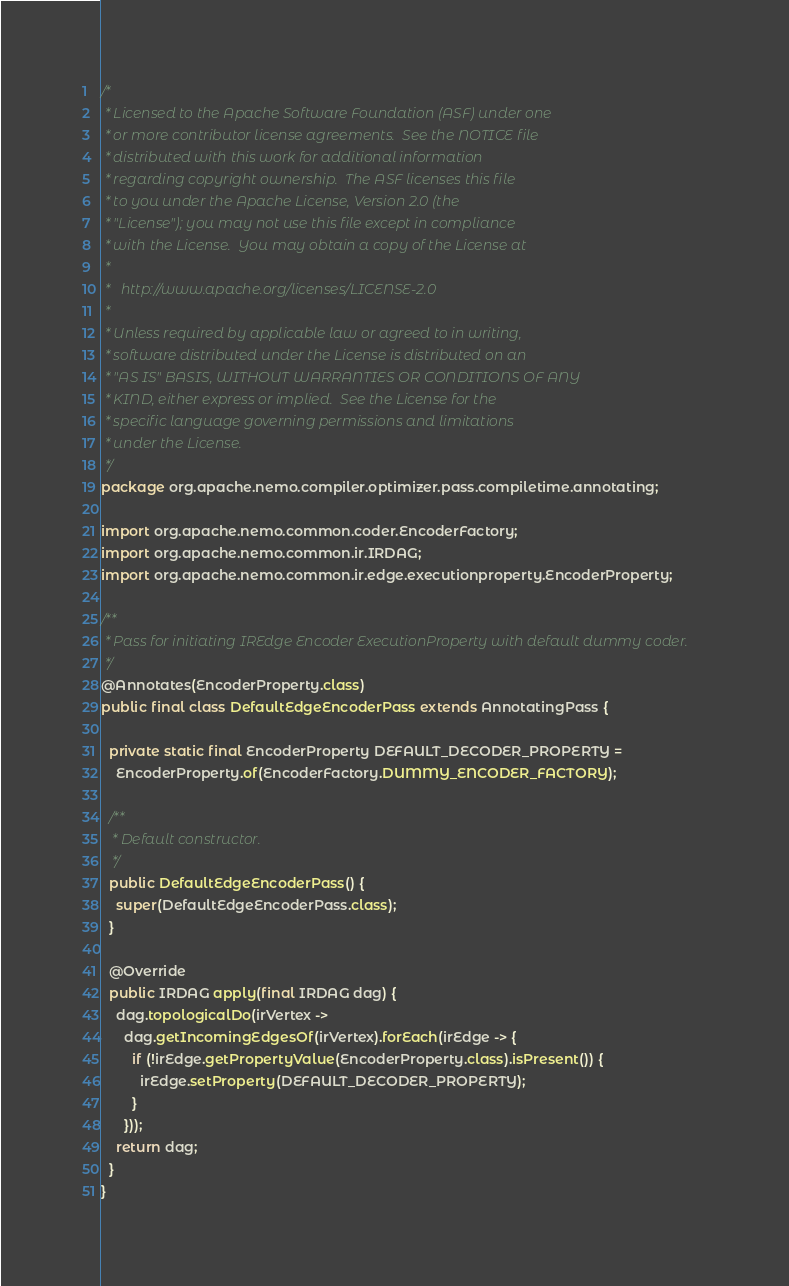<code> <loc_0><loc_0><loc_500><loc_500><_Java_>/*
 * Licensed to the Apache Software Foundation (ASF) under one
 * or more contributor license agreements.  See the NOTICE file
 * distributed with this work for additional information
 * regarding copyright ownership.  The ASF licenses this file
 * to you under the Apache License, Version 2.0 (the
 * "License"); you may not use this file except in compliance
 * with the License.  You may obtain a copy of the License at
 *
 *   http://www.apache.org/licenses/LICENSE-2.0
 *
 * Unless required by applicable law or agreed to in writing,
 * software distributed under the License is distributed on an
 * "AS IS" BASIS, WITHOUT WARRANTIES OR CONDITIONS OF ANY
 * KIND, either express or implied.  See the License for the
 * specific language governing permissions and limitations
 * under the License.
 */
package org.apache.nemo.compiler.optimizer.pass.compiletime.annotating;

import org.apache.nemo.common.coder.EncoderFactory;
import org.apache.nemo.common.ir.IRDAG;
import org.apache.nemo.common.ir.edge.executionproperty.EncoderProperty;

/**
 * Pass for initiating IREdge Encoder ExecutionProperty with default dummy coder.
 */
@Annotates(EncoderProperty.class)
public final class DefaultEdgeEncoderPass extends AnnotatingPass {

  private static final EncoderProperty DEFAULT_DECODER_PROPERTY =
    EncoderProperty.of(EncoderFactory.DUMMY_ENCODER_FACTORY);

  /**
   * Default constructor.
   */
  public DefaultEdgeEncoderPass() {
    super(DefaultEdgeEncoderPass.class);
  }

  @Override
  public IRDAG apply(final IRDAG dag) {
    dag.topologicalDo(irVertex ->
      dag.getIncomingEdgesOf(irVertex).forEach(irEdge -> {
        if (!irEdge.getPropertyValue(EncoderProperty.class).isPresent()) {
          irEdge.setProperty(DEFAULT_DECODER_PROPERTY);
        }
      }));
    return dag;
  }
}
</code> 